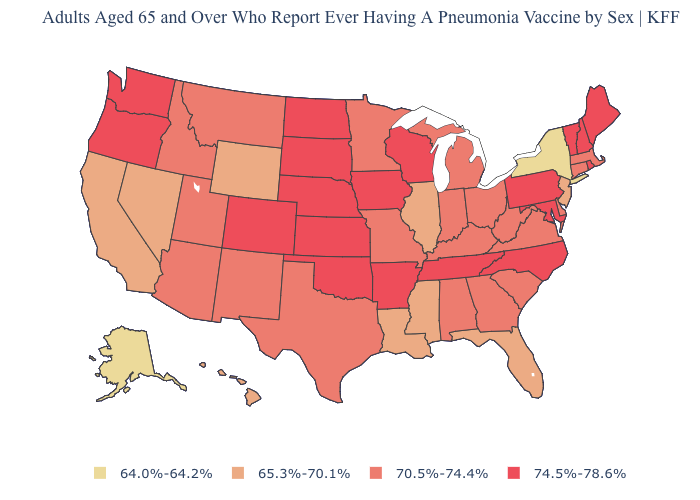What is the highest value in states that border Maryland?
Give a very brief answer. 74.5%-78.6%. What is the lowest value in the MidWest?
Write a very short answer. 65.3%-70.1%. What is the value of Georgia?
Concise answer only. 70.5%-74.4%. What is the value of North Dakota?
Quick response, please. 74.5%-78.6%. What is the highest value in the USA?
Answer briefly. 74.5%-78.6%. Among the states that border Nevada , which have the lowest value?
Keep it brief. California. Among the states that border Wyoming , does South Dakota have the highest value?
Write a very short answer. Yes. What is the highest value in the West ?
Short answer required. 74.5%-78.6%. What is the value of North Dakota?
Quick response, please. 74.5%-78.6%. What is the value of Vermont?
Quick response, please. 74.5%-78.6%. What is the lowest value in the USA?
Keep it brief. 64.0%-64.2%. Which states have the lowest value in the Northeast?
Concise answer only. New York. Does Rhode Island have a higher value than Alabama?
Short answer required. Yes. What is the value of Alaska?
Concise answer only. 64.0%-64.2%. What is the value of Tennessee?
Concise answer only. 74.5%-78.6%. 